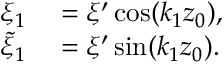<formula> <loc_0><loc_0><loc_500><loc_500>\begin{array} { r l } { \xi _ { 1 } } & = \xi ^ { \prime } \cos ( k _ { 1 } z _ { 0 } ) , } \\ { \tilde { \xi } _ { 1 } } & = \xi ^ { \prime } \sin ( k _ { 1 } z _ { 0 } ) . } \end{array}</formula> 